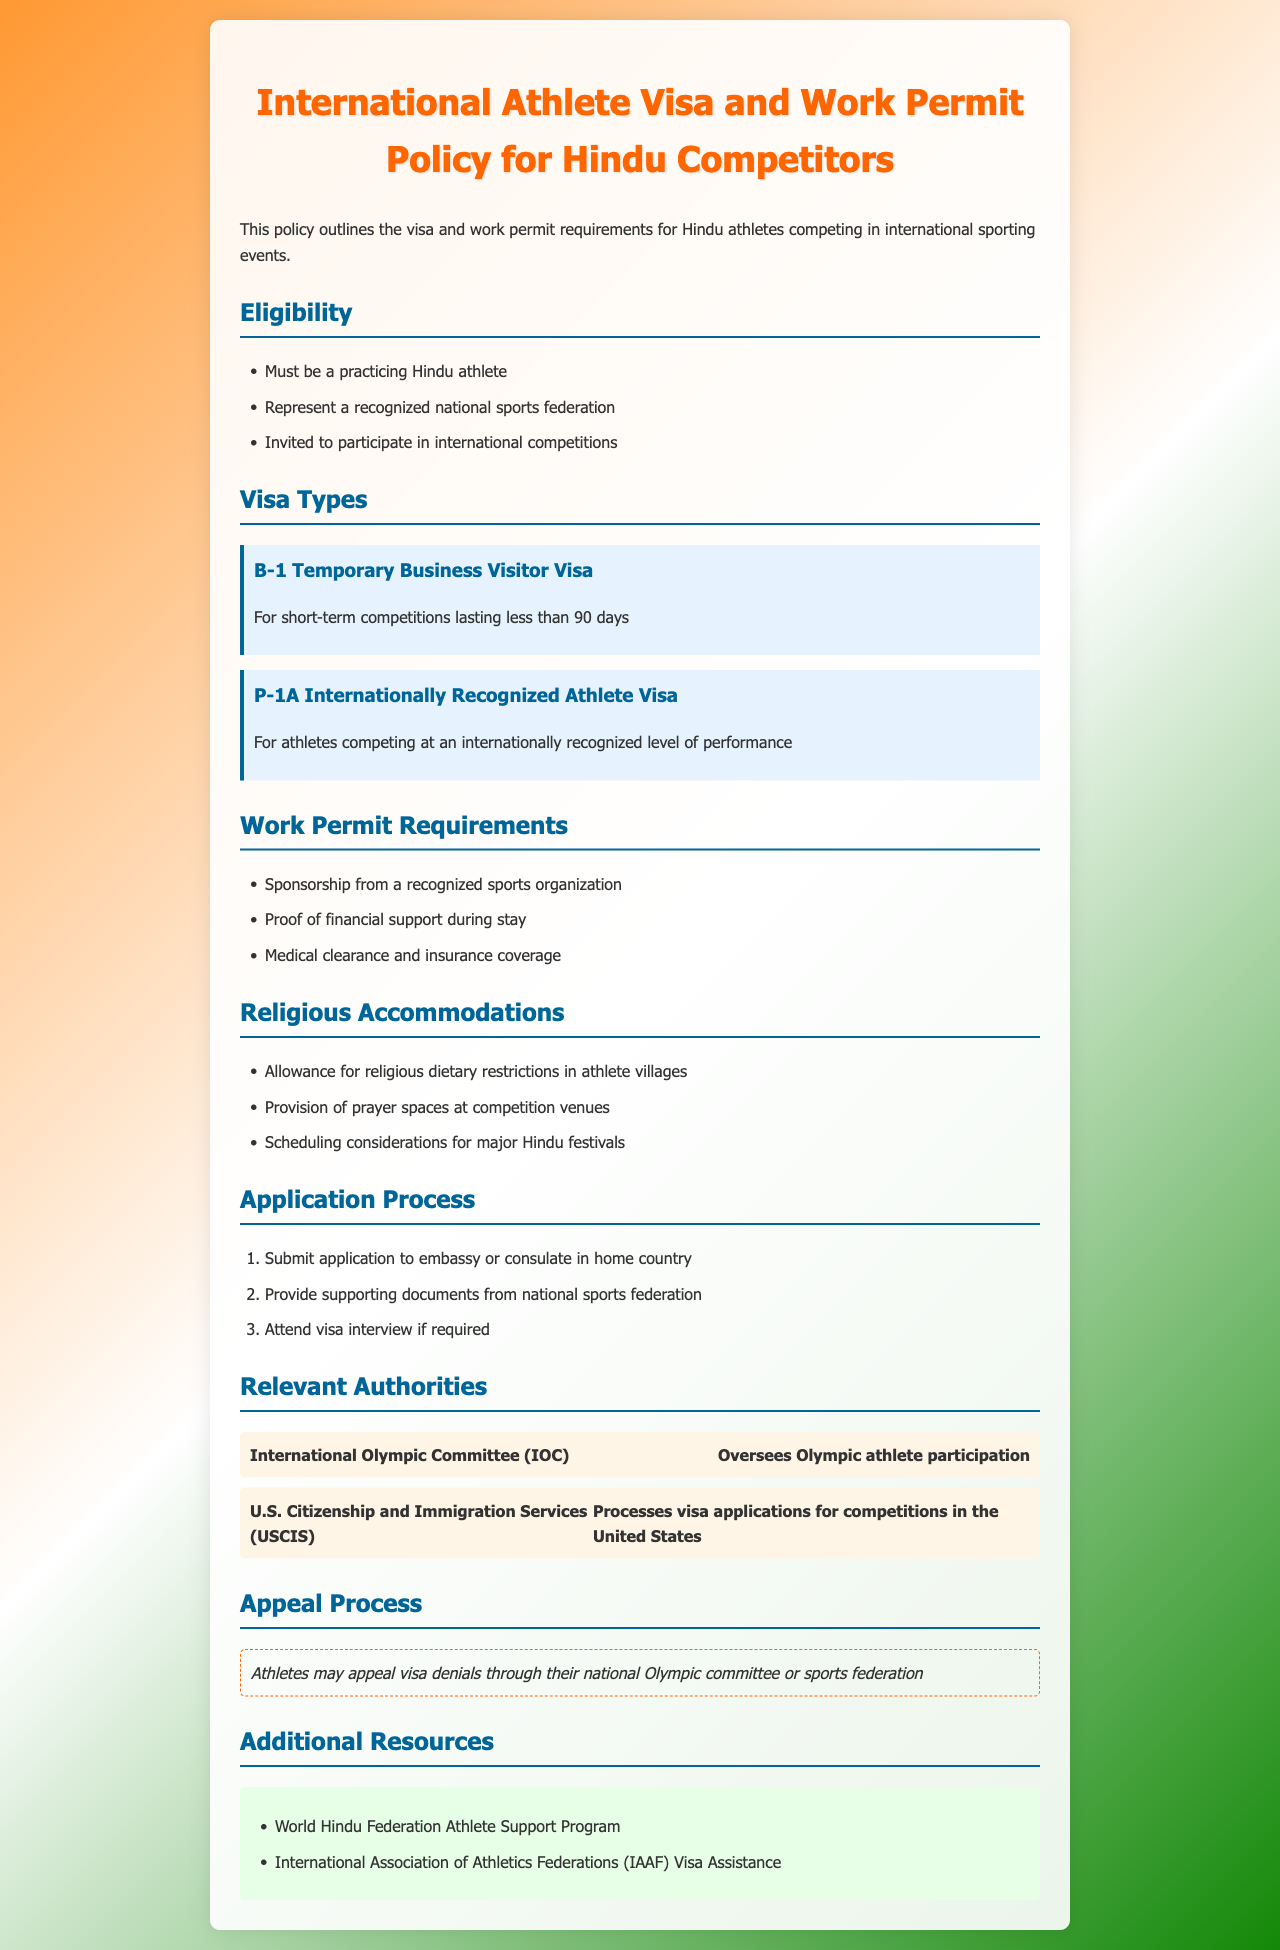What are the visa types listed? The document mentions visa types relevant for athletes, including B-1 Temporary Business Visitor Visa and P-1A Internationally Recognized Athlete Visa.
Answer: B-1 Temporary Business Visitor Visa, P-1A Internationally Recognized Athlete Visa What is a requirement to be eligible for the visa? The eligibility section outlines specific criteria that must be met, including being a practicing Hindu athlete and representing a recognized national sports federation.
Answer: Practicing Hindu athlete What is the maximum duration for the B-1 Visa? The visa type description for B-1 specifies it is for short-term competitions lasting less than a specific number of days.
Answer: Less than 90 days Who processes visa applications for competitions in the United States? The document lists relevant authorities, indicating that the U.S. Citizenship and Immigration Services is responsible for processing visa applications.
Answer: U.S. Citizenship and Immigration Services What must an athlete provide for a work permit? The work permit requirements section outlines specific documents or details the athlete must secure, such as sponsorship from a recognized sports organization.
Answer: Sponsorship from a recognized sports organization What type of process can athletes undertake if their visa is denied? The appeal process description suggests that athletes can pursue an appeal if their visa application is denied through their national Olympic committee or sports federation.
Answer: Appeal through national Olympic committee What type of dietary restrictions are accommodated? The religious accommodations mention specific considerations for the athletes, including dietary restrictions that must be honored in athlete villages.
Answer: Religious dietary restrictions How many steps are in the application process? The application process section lists several sequential actions that athletes must take, which can be counted for determining the number of steps.
Answer: Three steps 